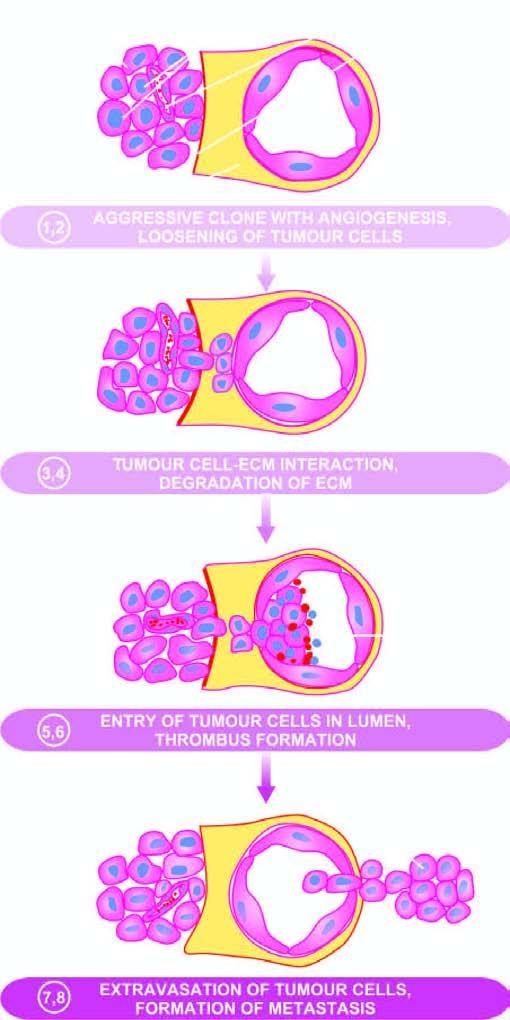what correspond to their description in the text?
Answer the question using a single word or phrase. Serial numbers in the figure 